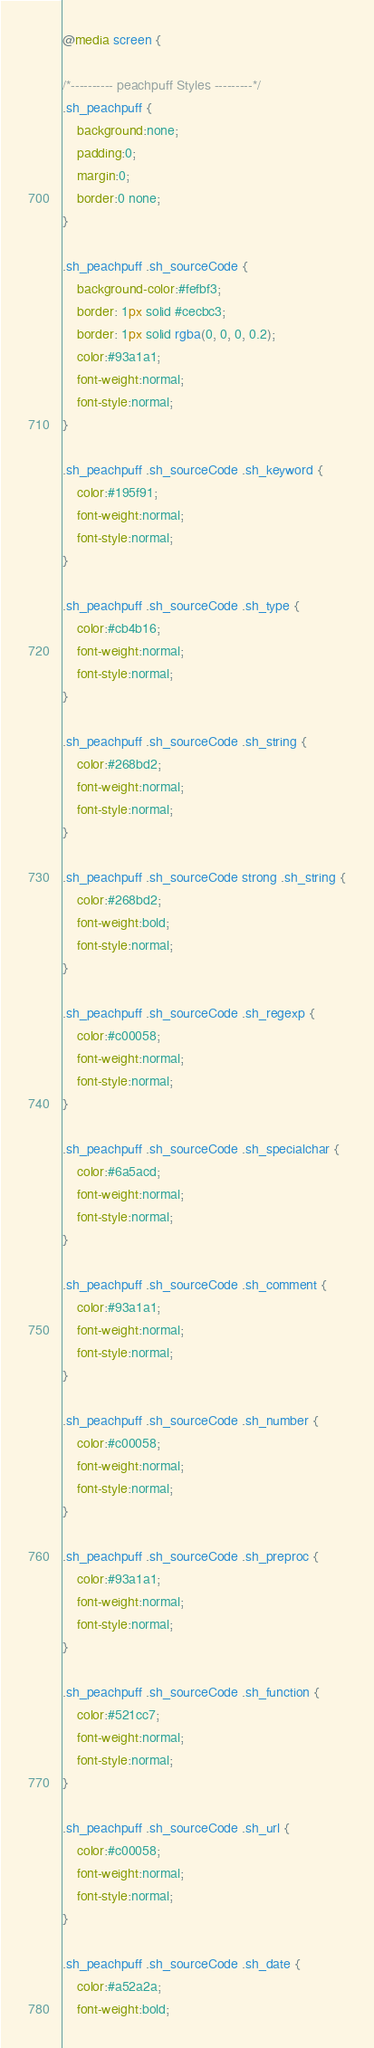Convert code to text. <code><loc_0><loc_0><loc_500><loc_500><_CSS_>@media screen {

/*---------- peachpuff Styles ---------*/
.sh_peachpuff {
	background:none;
	padding:0;
	margin:0;
	border:0 none;
}

.sh_peachpuff .sh_sourceCode {
	background-color:#fefbf3;
	border: 1px solid #cecbc3;
	border: 1px solid rgba(0, 0, 0, 0.2);
	color:#93a1a1;
	font-weight:normal;
	font-style:normal;
}

.sh_peachpuff .sh_sourceCode .sh_keyword {
	color:#195f91;
	font-weight:normal;
	font-style:normal;
}

.sh_peachpuff .sh_sourceCode .sh_type {
	color:#cb4b16;
	font-weight:normal;
	font-style:normal;
}

.sh_peachpuff .sh_sourceCode .sh_string {
	color:#268bd2;
	font-weight:normal;
	font-style:normal;
}

.sh_peachpuff .sh_sourceCode strong .sh_string {
	color:#268bd2;
	font-weight:bold;
	font-style:normal;
}

.sh_peachpuff .sh_sourceCode .sh_regexp {
	color:#c00058;
	font-weight:normal;
	font-style:normal;
}

.sh_peachpuff .sh_sourceCode .sh_specialchar {
	color:#6a5acd;
	font-weight:normal;
	font-style:normal;
}

.sh_peachpuff .sh_sourceCode .sh_comment {
	color:#93a1a1;
	font-weight:normal;
	font-style:normal;
}

.sh_peachpuff .sh_sourceCode .sh_number {
	color:#c00058;
	font-weight:normal;
	font-style:normal;
}

.sh_peachpuff .sh_sourceCode .sh_preproc {
	color:#93a1a1;
	font-weight:normal;
	font-style:normal;
}

.sh_peachpuff .sh_sourceCode .sh_function {
	color:#521cc7;
	font-weight:normal;
	font-style:normal;
}

.sh_peachpuff .sh_sourceCode .sh_url {
	color:#c00058;
	font-weight:normal;
	font-style:normal;
}

.sh_peachpuff .sh_sourceCode .sh_date {
	color:#a52a2a;
	font-weight:bold;</code> 